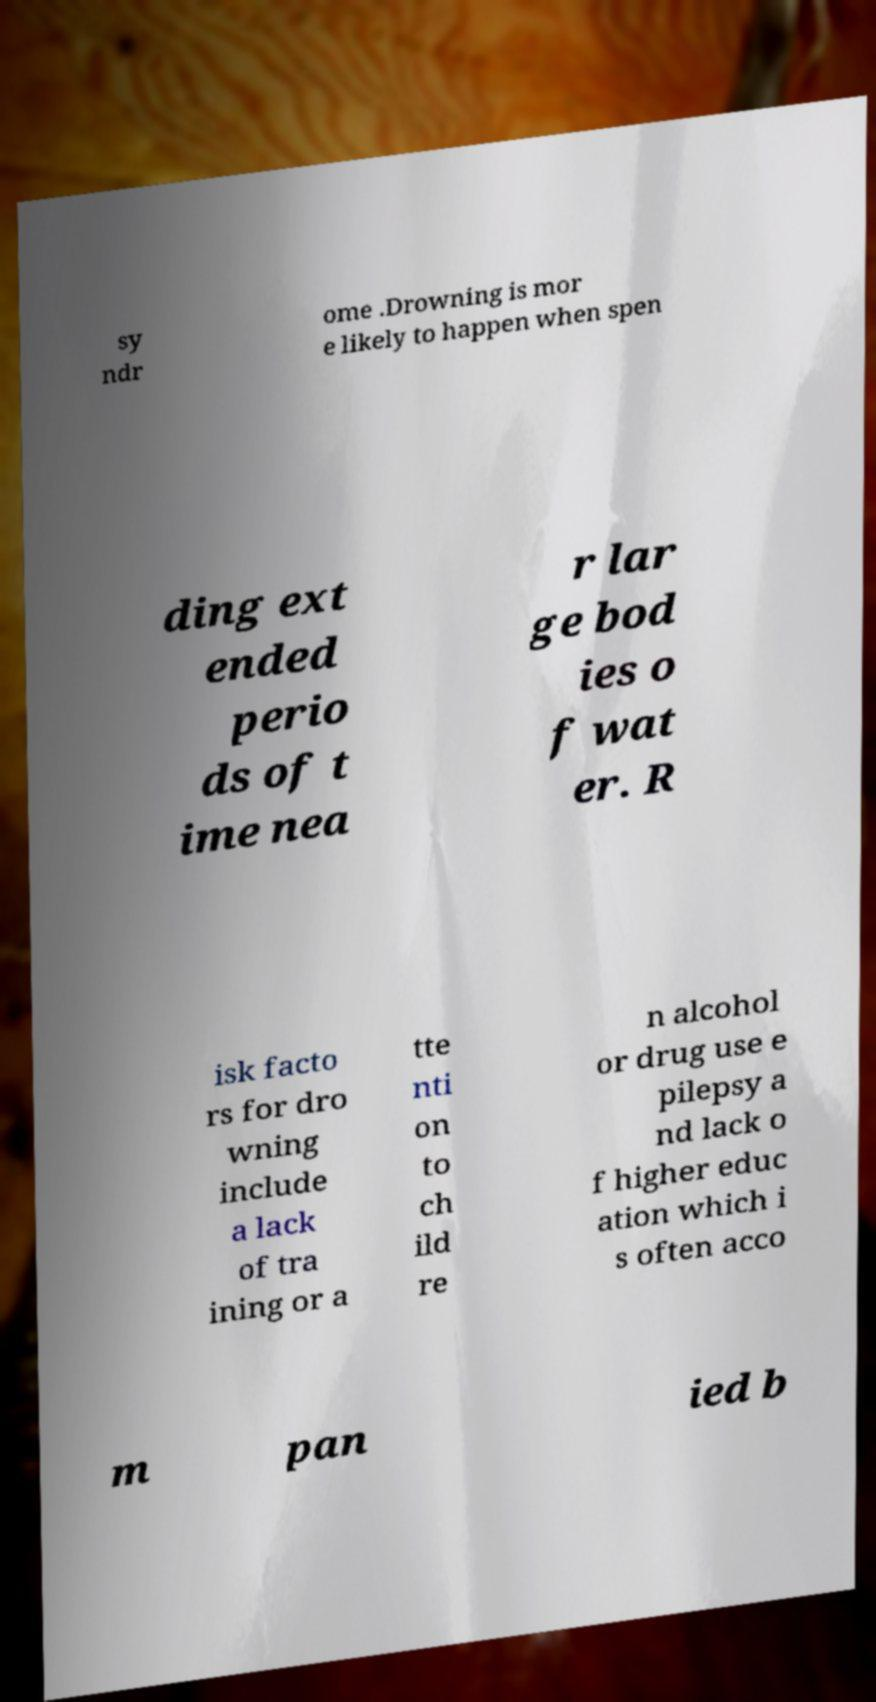For documentation purposes, I need the text within this image transcribed. Could you provide that? sy ndr ome .Drowning is mor e likely to happen when spen ding ext ended perio ds of t ime nea r lar ge bod ies o f wat er. R isk facto rs for dro wning include a lack of tra ining or a tte nti on to ch ild re n alcohol or drug use e pilepsy a nd lack o f higher educ ation which i s often acco m pan ied b 